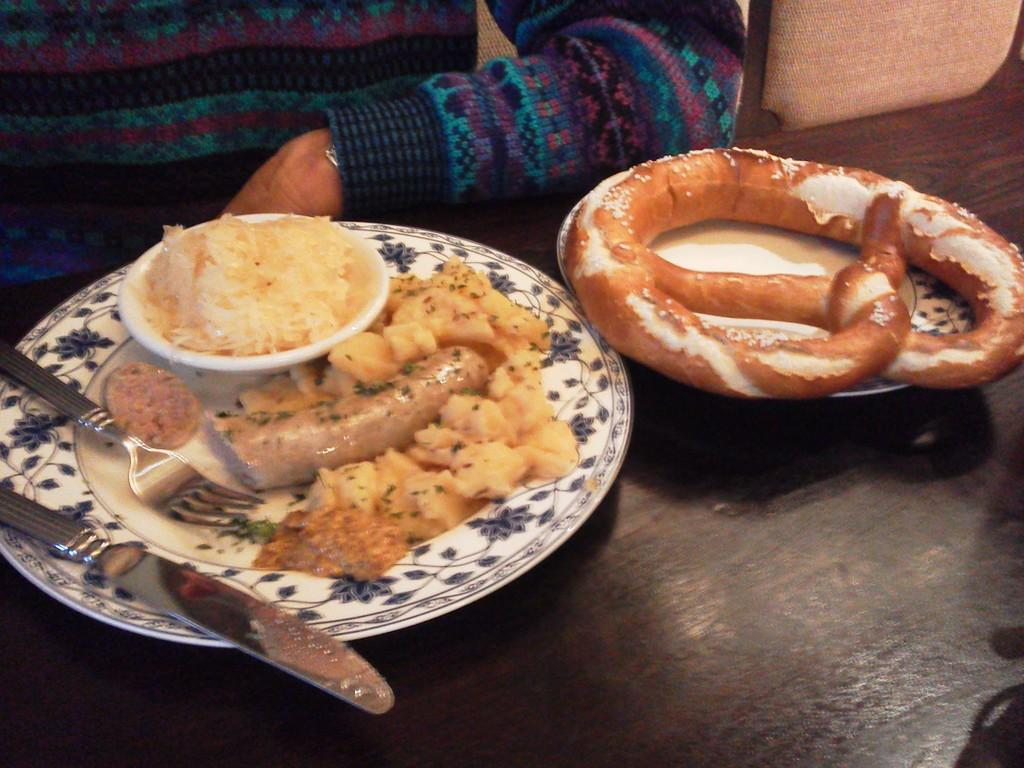What is on the plate that is visible in the image? There are food items on a plate in the image. Where is the plate located in the image? The plate is placed on a table in the image. What utensils are visible in the image? There is a fork and a dinner knife in the image. Can you describe the person's position in relation to the table in the image? There is a person sitting near the table in the image. What type of bridge can be seen in the background of the image? There is no bridge visible in the image; it only features a plate of food, utensils, and a person sitting near the table. 